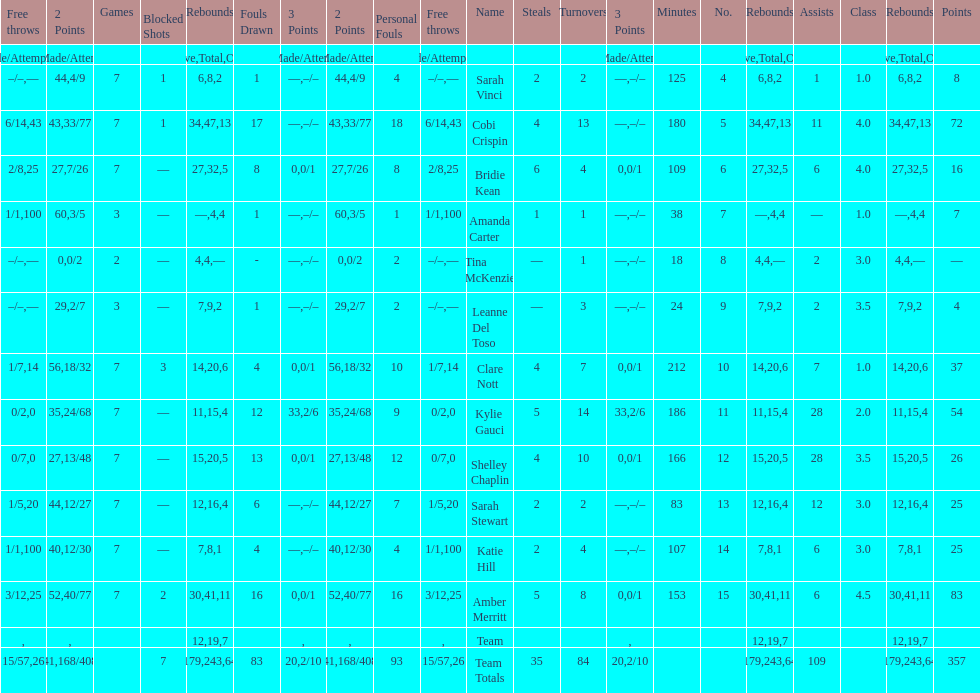What is the difference between the highest scoring player's points and the lowest scoring player's points? 83. 